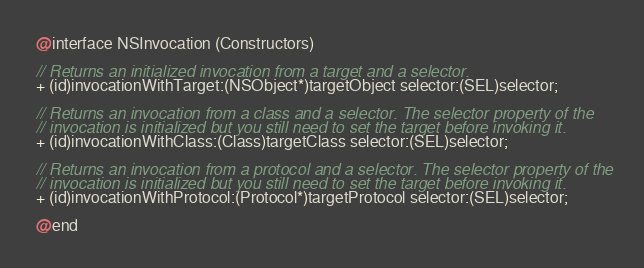Convert code to text. <code><loc_0><loc_0><loc_500><loc_500><_C_>
@interface NSInvocation (Constructors)

// Returns an initialized invocation from a target and a selector.
+ (id)invocationWithTarget:(NSObject*)targetObject selector:(SEL)selector;

// Returns an invocation from a class and a selector. The selector property of the
// invocation is initialized but you still need to set the target before invoking it.
+ (id)invocationWithClass:(Class)targetClass selector:(SEL)selector;

// Returns an invocation from a protocol and a selector. The selector property of the
// invocation is initialized but you still need to set the target before invoking it.
+ (id)invocationWithProtocol:(Protocol*)targetProtocol selector:(SEL)selector;

@end</code> 